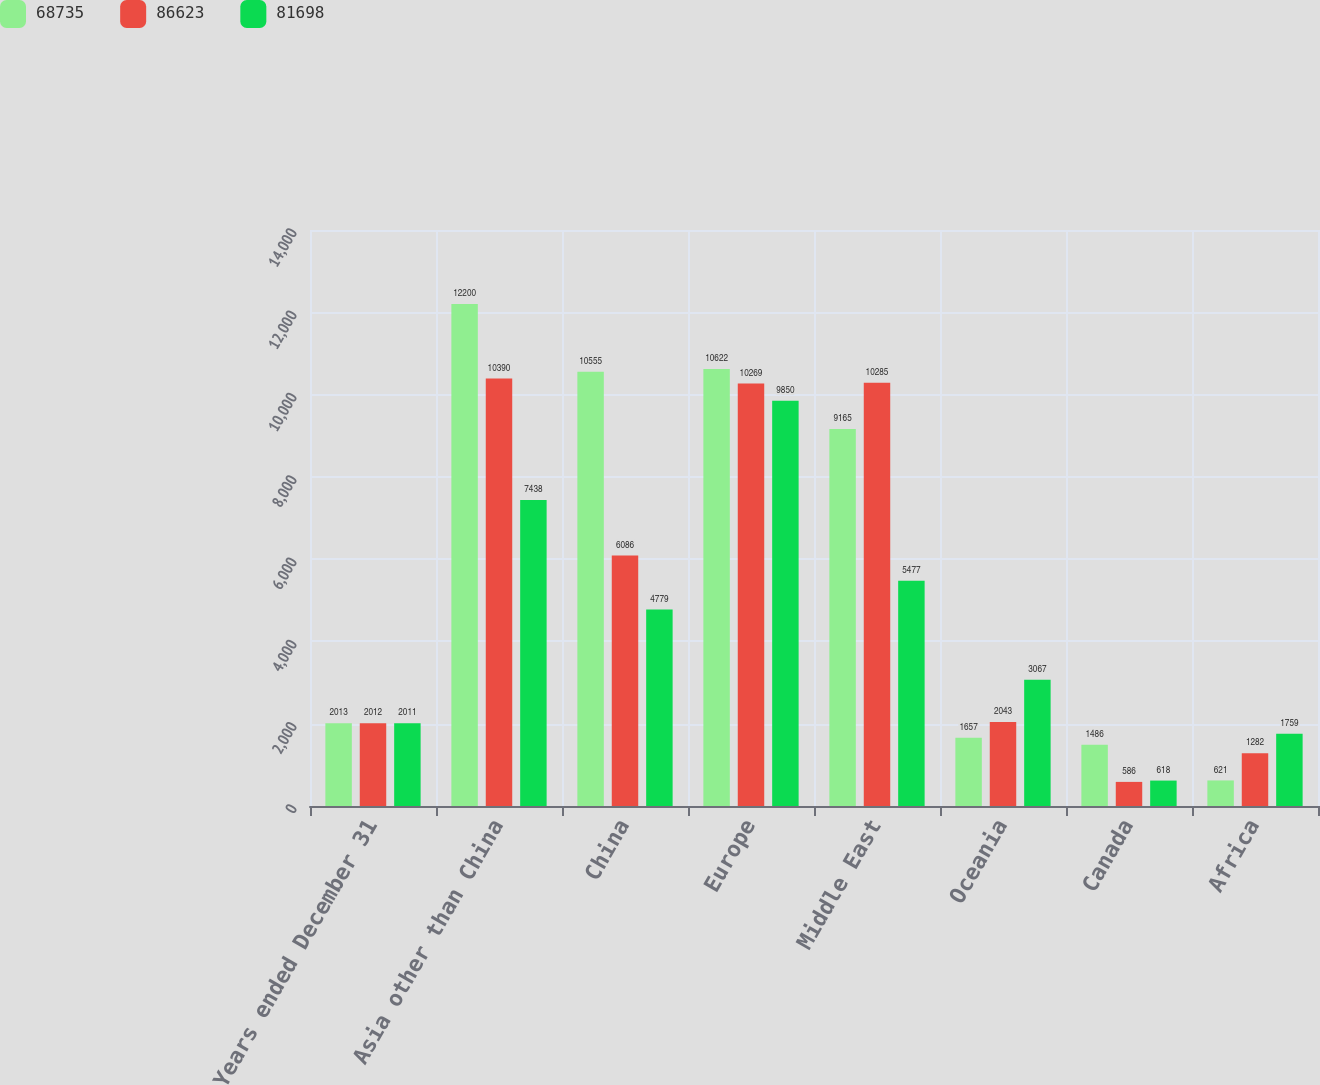<chart> <loc_0><loc_0><loc_500><loc_500><stacked_bar_chart><ecel><fcel>Years ended December 31<fcel>Asia other than China<fcel>China<fcel>Europe<fcel>Middle East<fcel>Oceania<fcel>Canada<fcel>Africa<nl><fcel>68735<fcel>2013<fcel>12200<fcel>10555<fcel>10622<fcel>9165<fcel>1657<fcel>1486<fcel>621<nl><fcel>86623<fcel>2012<fcel>10390<fcel>6086<fcel>10269<fcel>10285<fcel>2043<fcel>586<fcel>1282<nl><fcel>81698<fcel>2011<fcel>7438<fcel>4779<fcel>9850<fcel>5477<fcel>3067<fcel>618<fcel>1759<nl></chart> 